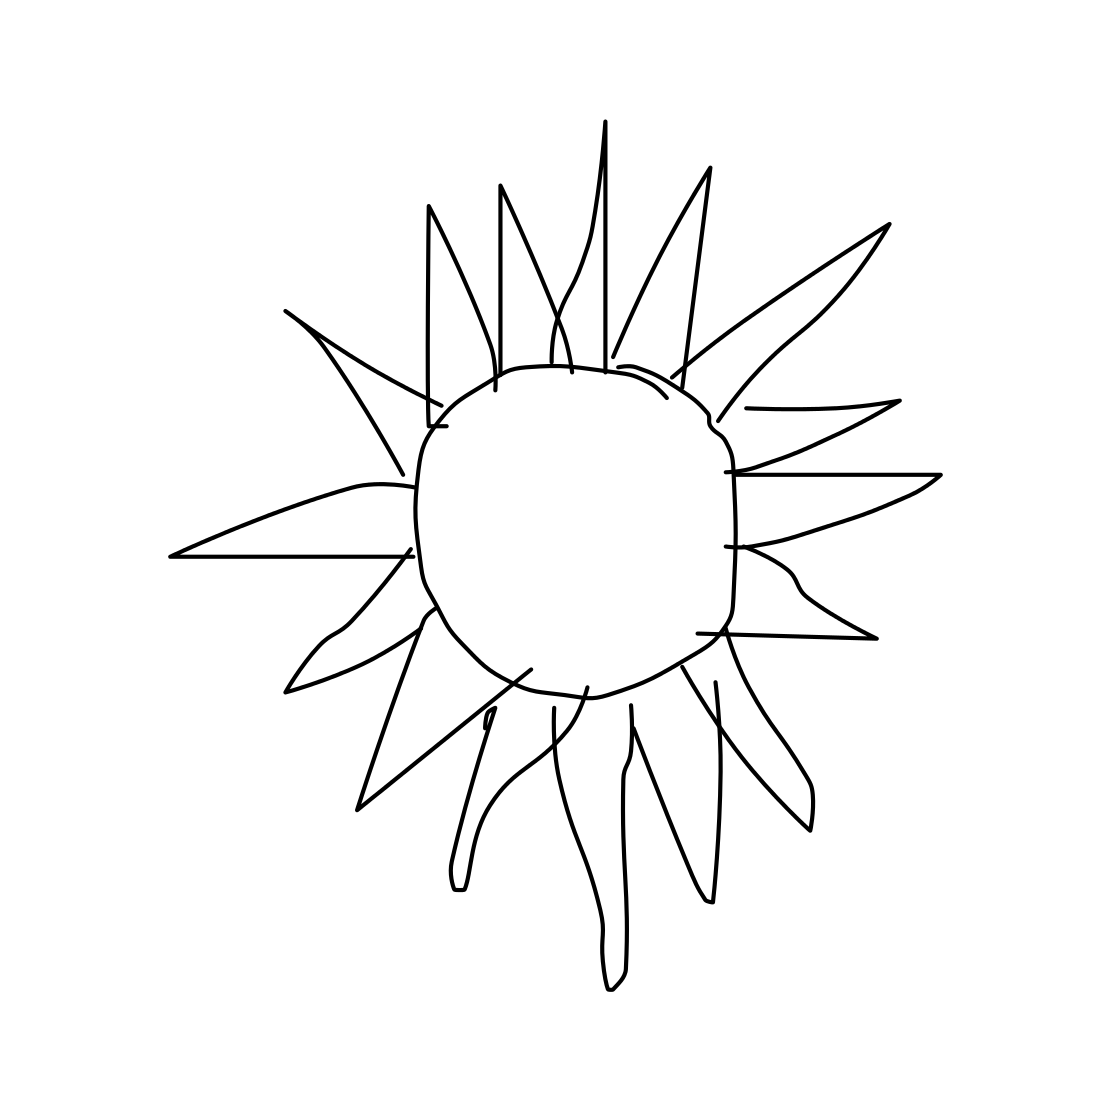Is this a guitar in the image? No 